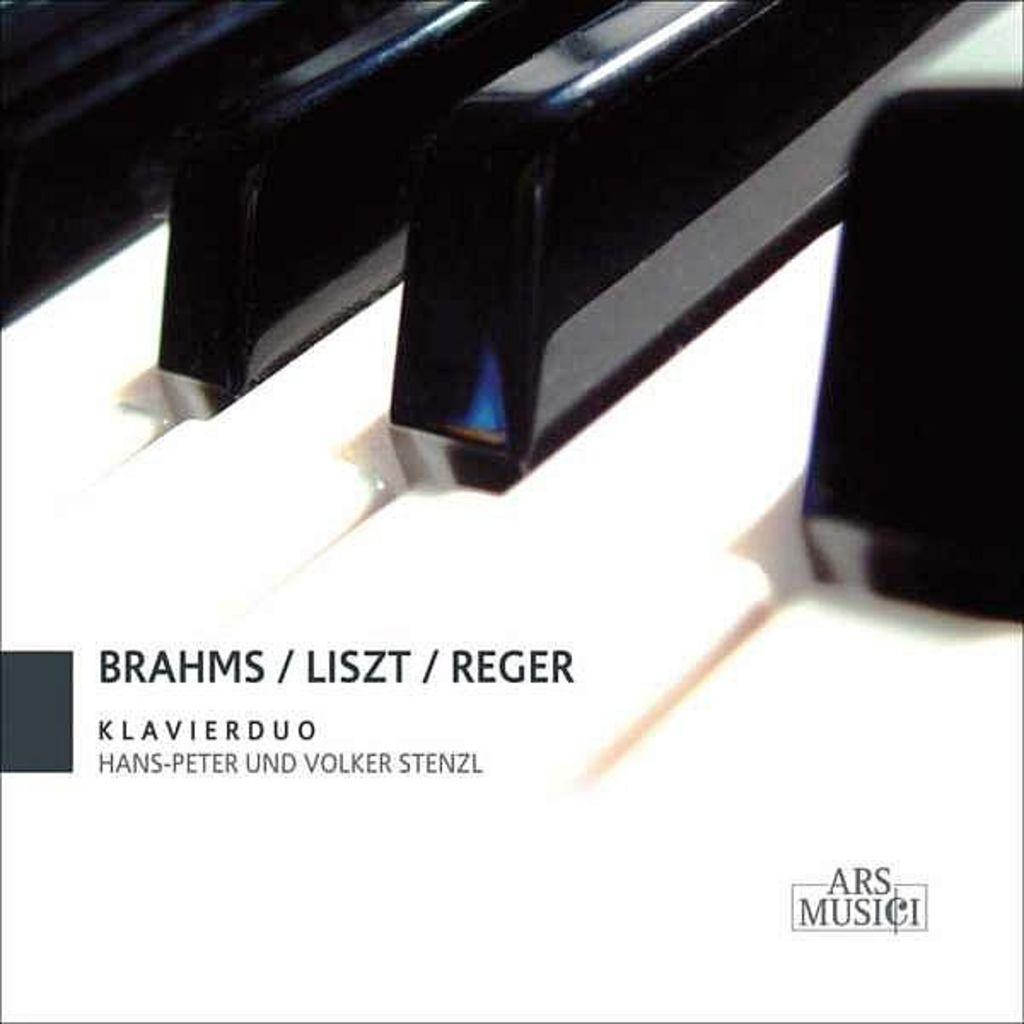What is the main object in the image? There is a piano in the image. Can you describe anything else on the left side of the image? There is text on the left side of the image. What type of button is being pressed by the brother in the image? There is no brother or button present in the image. What type of tank is visible in the background of the image? There is no tank visible in the image; it only features a piano and text. 